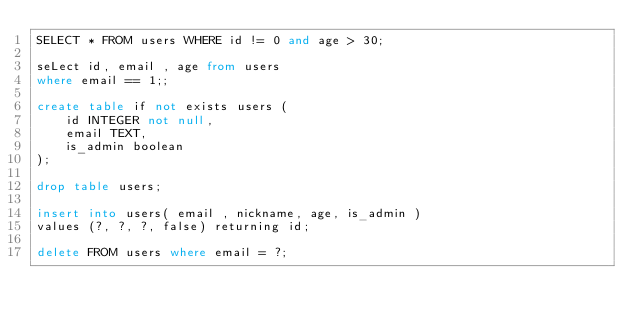<code> <loc_0><loc_0><loc_500><loc_500><_SQL_>SELECT * FROM users WHERE id != 0 and age > 30;

seLect id, email , age from users
where email == 1;;

create table if not exists users (
    id INTEGER not null,
    email TEXT,
    is_admin boolean
);

drop table users;

insert into users( email , nickname, age, is_admin )
values (?, ?, ?, false) returning id;

delete FROM users where email = ?;
</code> 